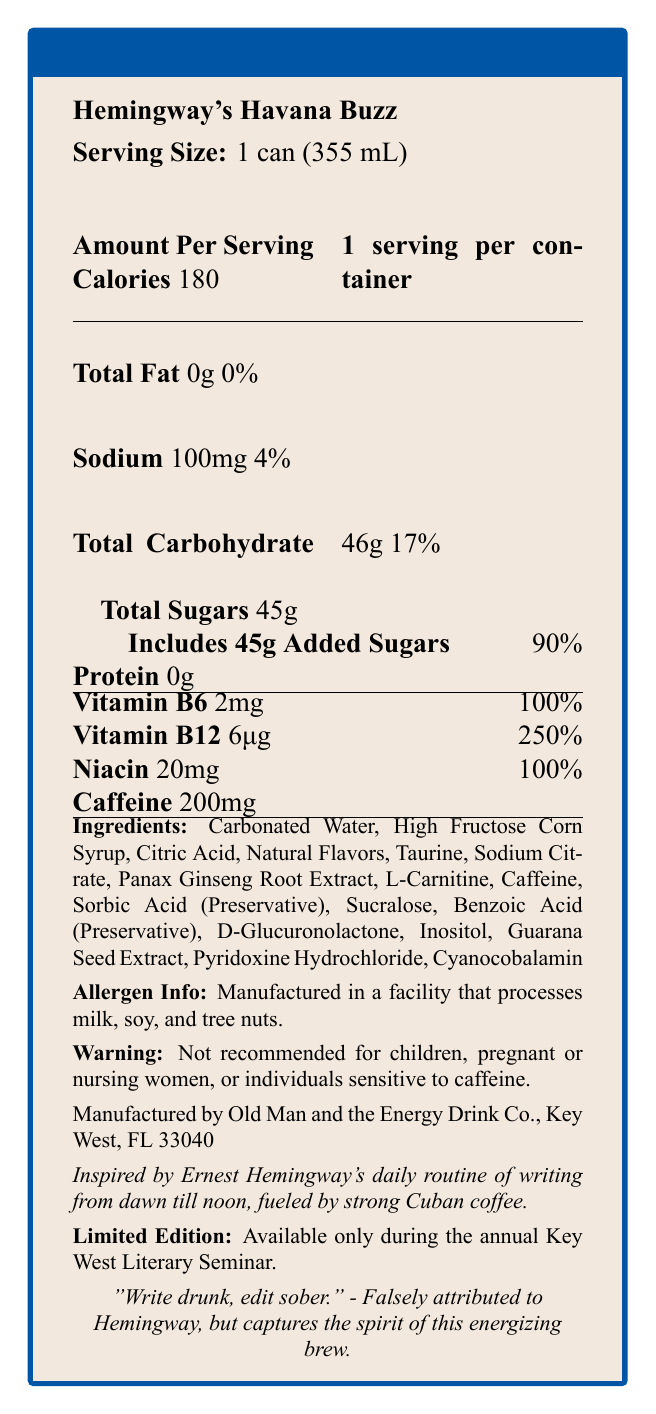what is the serving size of Hemingway's Havana Buzz? The serving size is listed as 1 can (355 mL) in the document.
Answer: 1 can (355 mL) how many calories are in one serving? The document specifies that there are 180 calories per serving.
Answer: 180 what is the total amount of sugars in one serving? The document notes that the total amount of sugars is 45g.
Answer: 45g how much caffeine does one can contain? The caffeine content is listed as 200mg per can.
Answer: 200mg list three vitamins or minerals included in the drink along with their amounts. These vitamins and their amounts are listed under vitamins and minerals in the document.
Answer: Vitamin B6: 2mg, Vitamin B12: 6μg, Niacin: 20mg what is the sodium content in one can? The sodium content is listed as 100mg per serving.
Answer: 100mg what is the daily value percentage of added sugars? A. 50% B. 75% C. 90% D. 100% The document lists 90% as the daily value percentage for added sugars.
Answer: C how many total carbohydrates are in the drink? A. 40g B. 46g C. 50g D. 55g The total carbohydrate content is listed as 46g.
Answer: B is the product recommended for children? The document states that it's not recommended for children.
Answer: No what is the main inspiration behind Hemingway's Havana Buzz? The document notes that the inspiration is Hemingway's daily routine of writing while fueled by strong Cuban coffee.
Answer: Ernest Hemingway's daily routine of writing from dawn till noon, fueled by strong Cuban coffee which company manufactures this energy drink? The manufacturer's information is listed in the document.
Answer: Old Man and the Energy Drink Co., Key West, FL 33040 what allergens are potentially present in this product? The document states that it is manufactured in a facility that processes these allergens.
Answer: Milk, soy, and tree nuts describe the main idea of the nutrient label and the product. The document provides a nutrition breakdown and inspiration behind the drink, highlighting its energy-boosting properties and unique tie to Hemingway.
Answer: Hemingway's Havana Buzz is a limited-edition energy drink inspired by Ernest Hemingway's writing routine. It contains 180 calories, 200mg of caffeine, and high levels of Vitamin B6, B12, and Niacin. The product is geared towards adults and has a high sugar content. how many servings are there per container? The document explicitly states that there is 1 serving per container.
Answer: 1 list all ingredients that can be found in Hemingway's Havana Buzz. The ingredient list is detailed in the document.
Answer: Carbonated Water, High Fructose Corn Syrup, Citric Acid, Natural Flavors, Taurine, Sodium Citrate, Panax Ginseng Root Extract, L-Carnitine, Caffeine, Sorbic Acid (Preservative), Sucralose, Benzoic Acid (Preservative), D-Glucuronolactone, Inositol, Guarana Seed Extract, Pyridoxine Hydrochloride, Cyanocobalamin what is the daily value percentage of Vitamin B12 provided in the drink? The daily value percentage for Vitamin B12 is listed as 250%.
Answer: 250% can this drink be purchased year-round? The document states that it's available only during the annual Key West Literary Seminar.
Answer: No what specific literary quote is associated with the drink? The document includes this quote under the marketing section.
Answer: "Write drunk, edit sober." - Falsely attributed to Hemingway, but captures the spirit of this energizing brew. compare the protein content to the carbohydrate content in one serving. The protein content is listed as 0g, whereas carbohydrate content is 46g.
Answer: Protein: 0g, Carbohydrate: 46g how much niacin is included per serving and what is its daily value percentage? The document states that niacin is included in the amount of 20mg per serving with a 100% daily value.
Answer: 20mg, 100% is there any information about the drink's flavor? The document lists "Natural Flavors" but does not specify the flavor profile of the drink.
Answer: Not enough information 